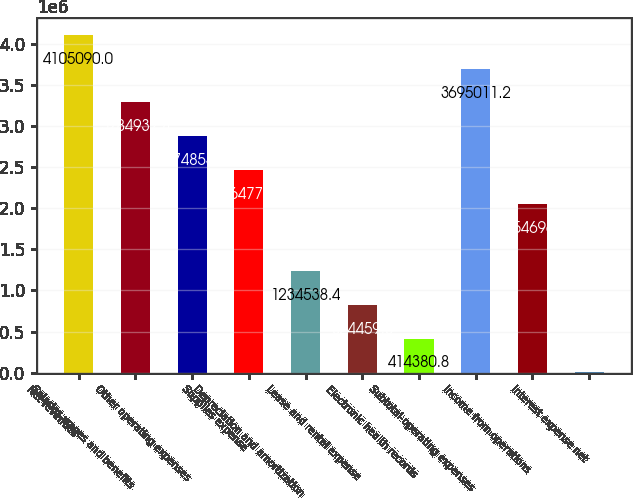Convert chart. <chart><loc_0><loc_0><loc_500><loc_500><bar_chart><fcel>Net revenues<fcel>Salaries wages and benefits<fcel>Other operating expenses<fcel>Supplies expense<fcel>Depreciation and amortization<fcel>Lease and rental expense<fcel>Electronic health records<fcel>Subtotal-operating expenses<fcel>Income from operations<fcel>Interest expense net<nl><fcel>4.10509e+06<fcel>3.28493e+06<fcel>2.87485e+06<fcel>2.46477e+06<fcel>1.23454e+06<fcel>824460<fcel>414381<fcel>3.69501e+06<fcel>2.0547e+06<fcel>4302<nl></chart> 